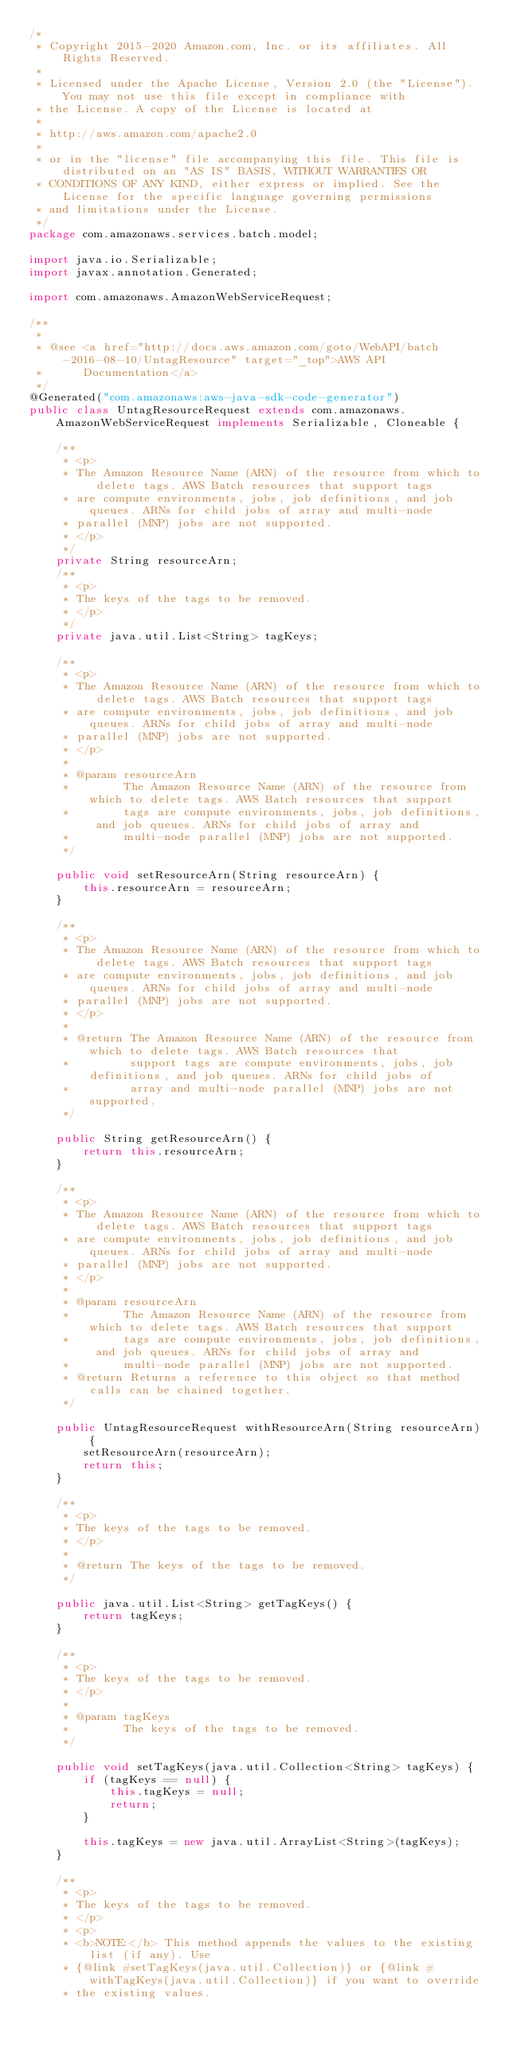Convert code to text. <code><loc_0><loc_0><loc_500><loc_500><_Java_>/*
 * Copyright 2015-2020 Amazon.com, Inc. or its affiliates. All Rights Reserved.
 * 
 * Licensed under the Apache License, Version 2.0 (the "License"). You may not use this file except in compliance with
 * the License. A copy of the License is located at
 * 
 * http://aws.amazon.com/apache2.0
 * 
 * or in the "license" file accompanying this file. This file is distributed on an "AS IS" BASIS, WITHOUT WARRANTIES OR
 * CONDITIONS OF ANY KIND, either express or implied. See the License for the specific language governing permissions
 * and limitations under the License.
 */
package com.amazonaws.services.batch.model;

import java.io.Serializable;
import javax.annotation.Generated;

import com.amazonaws.AmazonWebServiceRequest;

/**
 * 
 * @see <a href="http://docs.aws.amazon.com/goto/WebAPI/batch-2016-08-10/UntagResource" target="_top">AWS API
 *      Documentation</a>
 */
@Generated("com.amazonaws:aws-java-sdk-code-generator")
public class UntagResourceRequest extends com.amazonaws.AmazonWebServiceRequest implements Serializable, Cloneable {

    /**
     * <p>
     * The Amazon Resource Name (ARN) of the resource from which to delete tags. AWS Batch resources that support tags
     * are compute environments, jobs, job definitions, and job queues. ARNs for child jobs of array and multi-node
     * parallel (MNP) jobs are not supported.
     * </p>
     */
    private String resourceArn;
    /**
     * <p>
     * The keys of the tags to be removed.
     * </p>
     */
    private java.util.List<String> tagKeys;

    /**
     * <p>
     * The Amazon Resource Name (ARN) of the resource from which to delete tags. AWS Batch resources that support tags
     * are compute environments, jobs, job definitions, and job queues. ARNs for child jobs of array and multi-node
     * parallel (MNP) jobs are not supported.
     * </p>
     * 
     * @param resourceArn
     *        The Amazon Resource Name (ARN) of the resource from which to delete tags. AWS Batch resources that support
     *        tags are compute environments, jobs, job definitions, and job queues. ARNs for child jobs of array and
     *        multi-node parallel (MNP) jobs are not supported.
     */

    public void setResourceArn(String resourceArn) {
        this.resourceArn = resourceArn;
    }

    /**
     * <p>
     * The Amazon Resource Name (ARN) of the resource from which to delete tags. AWS Batch resources that support tags
     * are compute environments, jobs, job definitions, and job queues. ARNs for child jobs of array and multi-node
     * parallel (MNP) jobs are not supported.
     * </p>
     * 
     * @return The Amazon Resource Name (ARN) of the resource from which to delete tags. AWS Batch resources that
     *         support tags are compute environments, jobs, job definitions, and job queues. ARNs for child jobs of
     *         array and multi-node parallel (MNP) jobs are not supported.
     */

    public String getResourceArn() {
        return this.resourceArn;
    }

    /**
     * <p>
     * The Amazon Resource Name (ARN) of the resource from which to delete tags. AWS Batch resources that support tags
     * are compute environments, jobs, job definitions, and job queues. ARNs for child jobs of array and multi-node
     * parallel (MNP) jobs are not supported.
     * </p>
     * 
     * @param resourceArn
     *        The Amazon Resource Name (ARN) of the resource from which to delete tags. AWS Batch resources that support
     *        tags are compute environments, jobs, job definitions, and job queues. ARNs for child jobs of array and
     *        multi-node parallel (MNP) jobs are not supported.
     * @return Returns a reference to this object so that method calls can be chained together.
     */

    public UntagResourceRequest withResourceArn(String resourceArn) {
        setResourceArn(resourceArn);
        return this;
    }

    /**
     * <p>
     * The keys of the tags to be removed.
     * </p>
     * 
     * @return The keys of the tags to be removed.
     */

    public java.util.List<String> getTagKeys() {
        return tagKeys;
    }

    /**
     * <p>
     * The keys of the tags to be removed.
     * </p>
     * 
     * @param tagKeys
     *        The keys of the tags to be removed.
     */

    public void setTagKeys(java.util.Collection<String> tagKeys) {
        if (tagKeys == null) {
            this.tagKeys = null;
            return;
        }

        this.tagKeys = new java.util.ArrayList<String>(tagKeys);
    }

    /**
     * <p>
     * The keys of the tags to be removed.
     * </p>
     * <p>
     * <b>NOTE:</b> This method appends the values to the existing list (if any). Use
     * {@link #setTagKeys(java.util.Collection)} or {@link #withTagKeys(java.util.Collection)} if you want to override
     * the existing values.</code> 